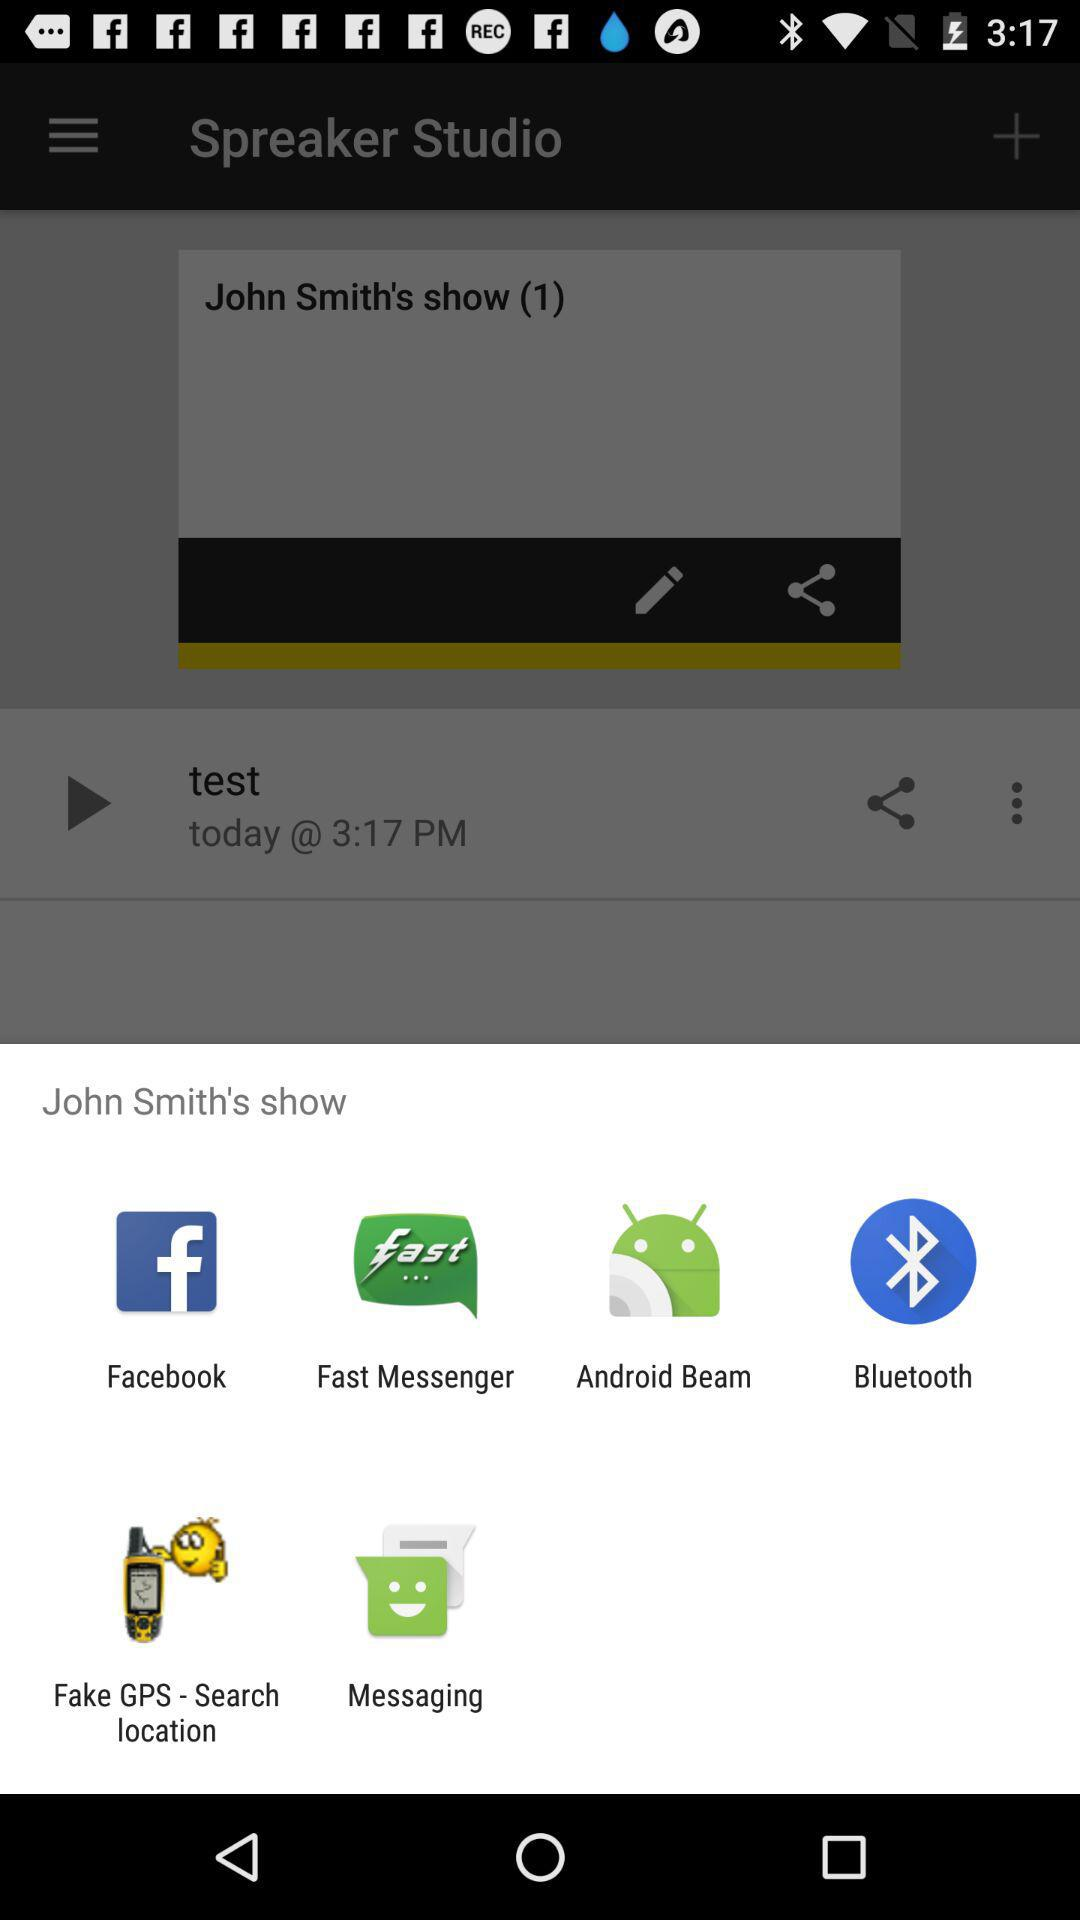What is the show name? The show's name is "John Smith's". 